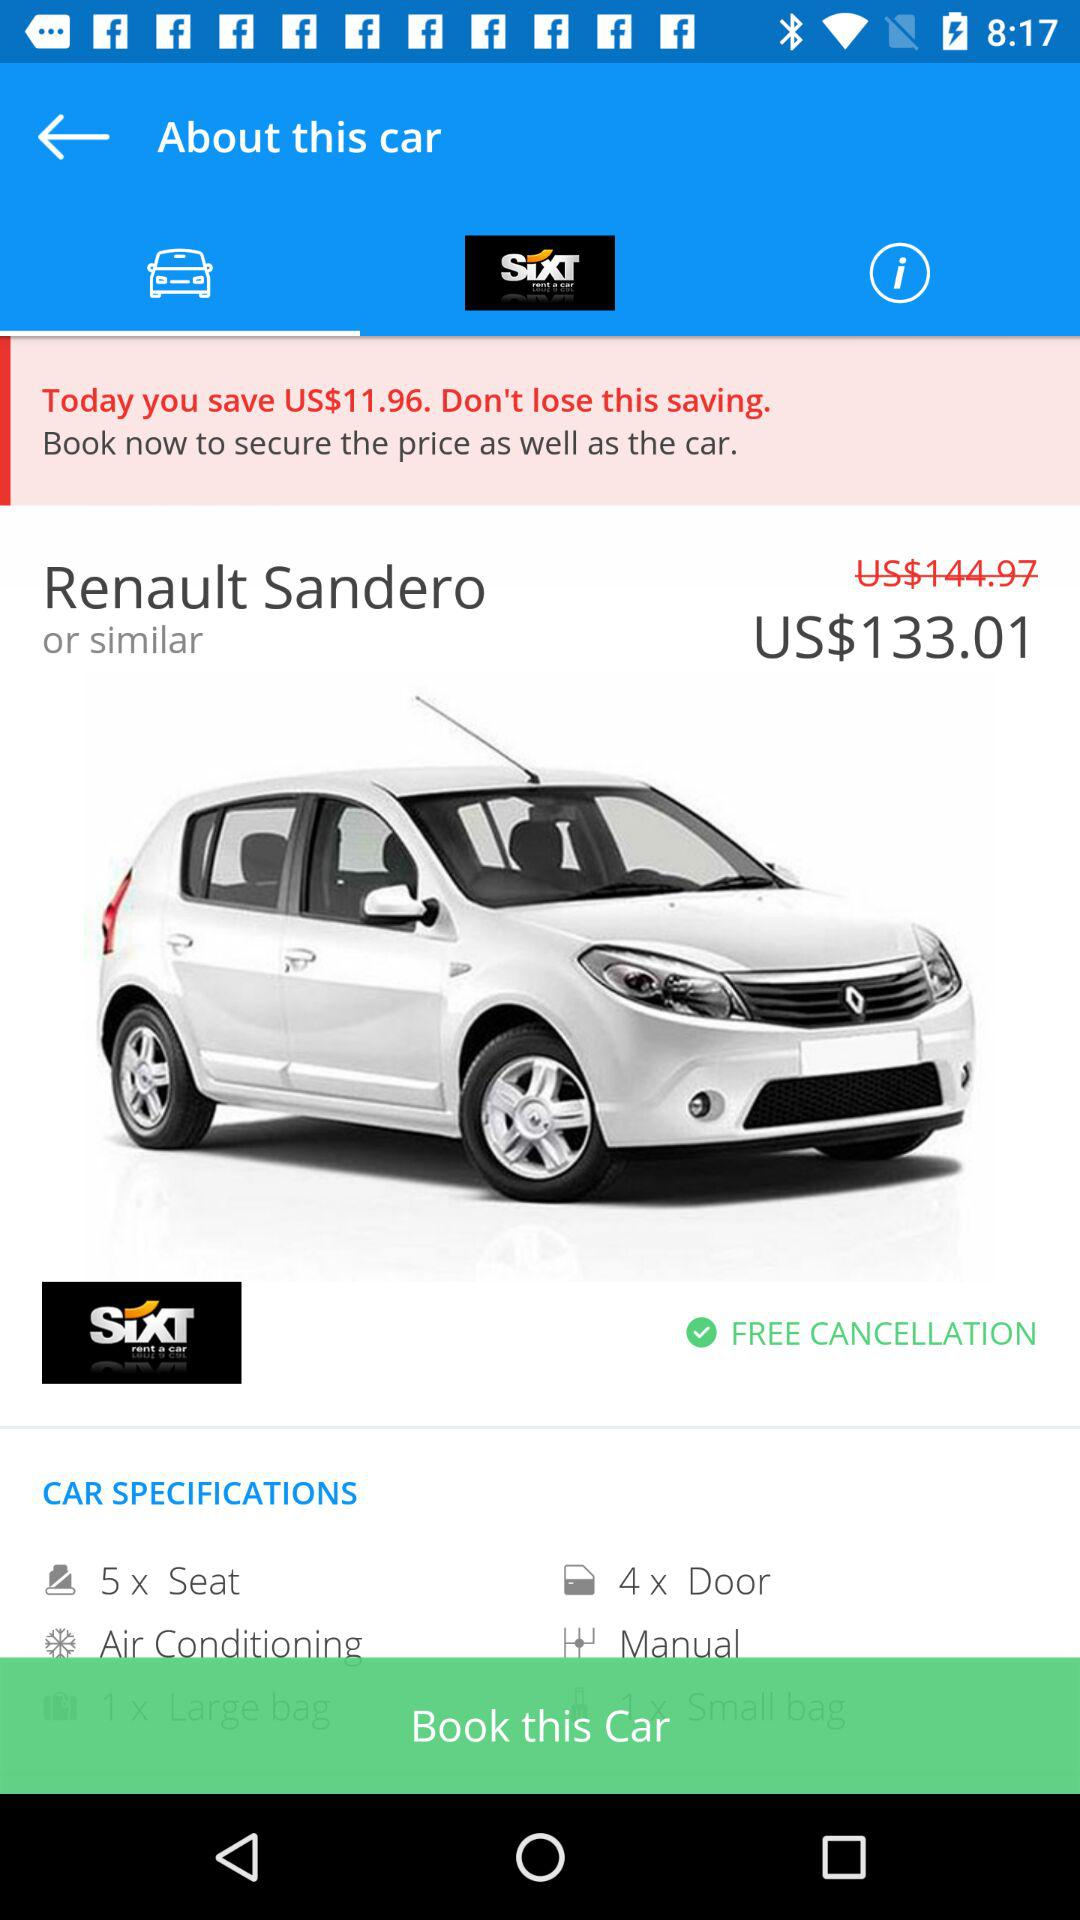How much do I save by booking now?
Answer the question using a single word or phrase. US$11.96 